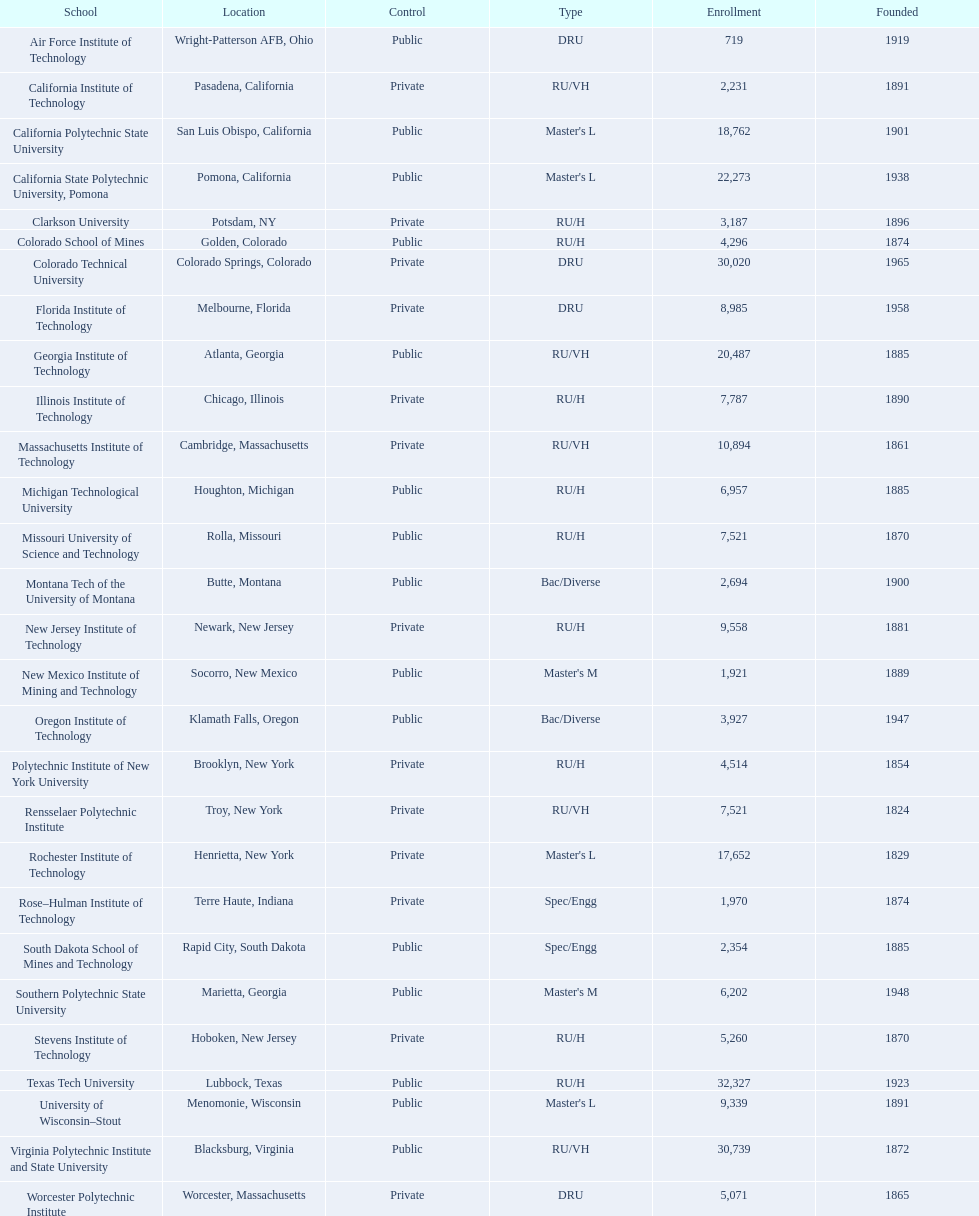What engineering colleges are present in the united states? Air Force Institute of Technology, California Institute of Technology, California Polytechnic State University, California State Polytechnic University, Pomona, Clarkson University, Colorado School of Mines, Colorado Technical University, Florida Institute of Technology, Georgia Institute of Technology, Illinois Institute of Technology, Massachusetts Institute of Technology, Michigan Technological University, Missouri University of Science and Technology, Montana Tech of the University of Montana, New Jersey Institute of Technology, New Mexico Institute of Mining and Technology, Oregon Institute of Technology, Polytechnic Institute of New York University, Rensselaer Polytechnic Institute, Rochester Institute of Technology, Rose–Hulman Institute of Technology, South Dakota School of Mines and Technology, Southern Polytechnic State University, Stevens Institute of Technology, Texas Tech University, University of Wisconsin–Stout, Virginia Polytechnic Institute and State University, Worcester Polytechnic Institute. Which has the largest student body? Texas Tech University. 